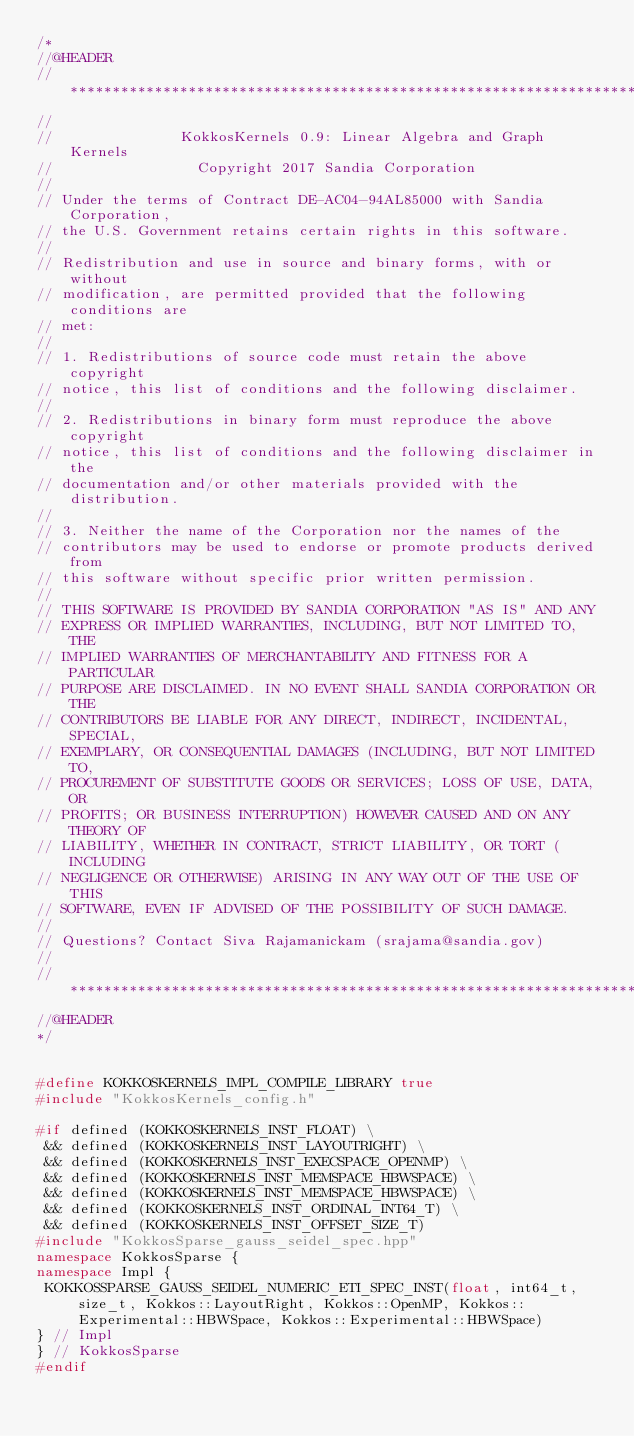<code> <loc_0><loc_0><loc_500><loc_500><_C++_>/*
//@HEADER
// ************************************************************************
//
//               KokkosKernels 0.9: Linear Algebra and Graph Kernels
//                 Copyright 2017 Sandia Corporation
//
// Under the terms of Contract DE-AC04-94AL85000 with Sandia Corporation,
// the U.S. Government retains certain rights in this software.
//
// Redistribution and use in source and binary forms, with or without
// modification, are permitted provided that the following conditions are
// met:
//
// 1. Redistributions of source code must retain the above copyright
// notice, this list of conditions and the following disclaimer.
//
// 2. Redistributions in binary form must reproduce the above copyright
// notice, this list of conditions and the following disclaimer in the
// documentation and/or other materials provided with the distribution.
//
// 3. Neither the name of the Corporation nor the names of the
// contributors may be used to endorse or promote products derived from
// this software without specific prior written permission.
//
// THIS SOFTWARE IS PROVIDED BY SANDIA CORPORATION "AS IS" AND ANY
// EXPRESS OR IMPLIED WARRANTIES, INCLUDING, BUT NOT LIMITED TO, THE
// IMPLIED WARRANTIES OF MERCHANTABILITY AND FITNESS FOR A PARTICULAR
// PURPOSE ARE DISCLAIMED. IN NO EVENT SHALL SANDIA CORPORATION OR THE
// CONTRIBUTORS BE LIABLE FOR ANY DIRECT, INDIRECT, INCIDENTAL, SPECIAL,
// EXEMPLARY, OR CONSEQUENTIAL DAMAGES (INCLUDING, BUT NOT LIMITED TO,
// PROCUREMENT OF SUBSTITUTE GOODS OR SERVICES; LOSS OF USE, DATA, OR
// PROFITS; OR BUSINESS INTERRUPTION) HOWEVER CAUSED AND ON ANY THEORY OF
// LIABILITY, WHETHER IN CONTRACT, STRICT LIABILITY, OR TORT (INCLUDING
// NEGLIGENCE OR OTHERWISE) ARISING IN ANY WAY OUT OF THE USE OF THIS
// SOFTWARE, EVEN IF ADVISED OF THE POSSIBILITY OF SUCH DAMAGE.
//
// Questions? Contact Siva Rajamanickam (srajama@sandia.gov)
//
// ************************************************************************
//@HEADER
*/


#define KOKKOSKERNELS_IMPL_COMPILE_LIBRARY true
#include "KokkosKernels_config.h"

#if defined (KOKKOSKERNELS_INST_FLOAT) \
 && defined (KOKKOSKERNELS_INST_LAYOUTRIGHT) \
 && defined (KOKKOSKERNELS_INST_EXECSPACE_OPENMP) \
 && defined (KOKKOSKERNELS_INST_MEMSPACE_HBWSPACE) \
 && defined (KOKKOSKERNELS_INST_MEMSPACE_HBWSPACE) \
 && defined (KOKKOSKERNELS_INST_ORDINAL_INT64_T) \
 && defined (KOKKOSKERNELS_INST_OFFSET_SIZE_T) 
#include "KokkosSparse_gauss_seidel_spec.hpp"
namespace KokkosSparse {
namespace Impl {
 KOKKOSSPARSE_GAUSS_SEIDEL_NUMERIC_ETI_SPEC_INST(float, int64_t, size_t, Kokkos::LayoutRight, Kokkos::OpenMP, Kokkos::Experimental::HBWSpace, Kokkos::Experimental::HBWSpace)
} // Impl
} // KokkosSparse
#endif
</code> 